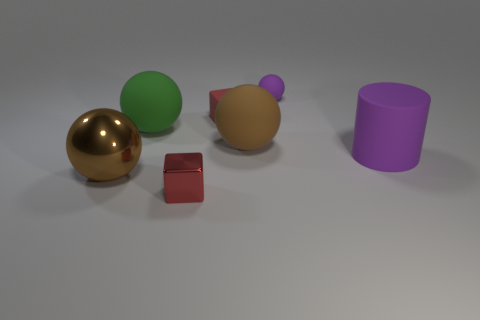What number of balls are both behind the green matte ball and in front of the cylinder?
Your answer should be compact. 0. How many other objects are the same color as the big cylinder?
Your answer should be compact. 1. There is a metal thing that is in front of the big metallic sphere; what shape is it?
Offer a very short reply. Cube. Are the small purple object and the large green sphere made of the same material?
Make the answer very short. Yes. Are there any other things that have the same size as the red matte cube?
Keep it short and to the point. Yes. There is a red metal object; what number of large purple matte cylinders are to the left of it?
Make the answer very short. 0. The big rubber object behind the large brown ball behind the purple cylinder is what shape?
Your answer should be very brief. Sphere. Is there any other thing that has the same shape as the big green object?
Keep it short and to the point. Yes. Are there more tiny purple objects that are in front of the green rubber ball than green rubber things?
Make the answer very short. No. There is a green rubber sphere to the right of the large brown shiny thing; how many small red cubes are behind it?
Ensure brevity in your answer.  1. 